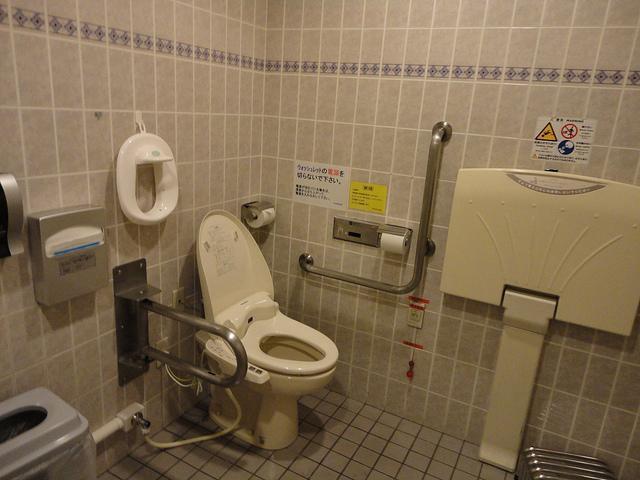How many handles does the vase have?
Give a very brief answer. 0. 